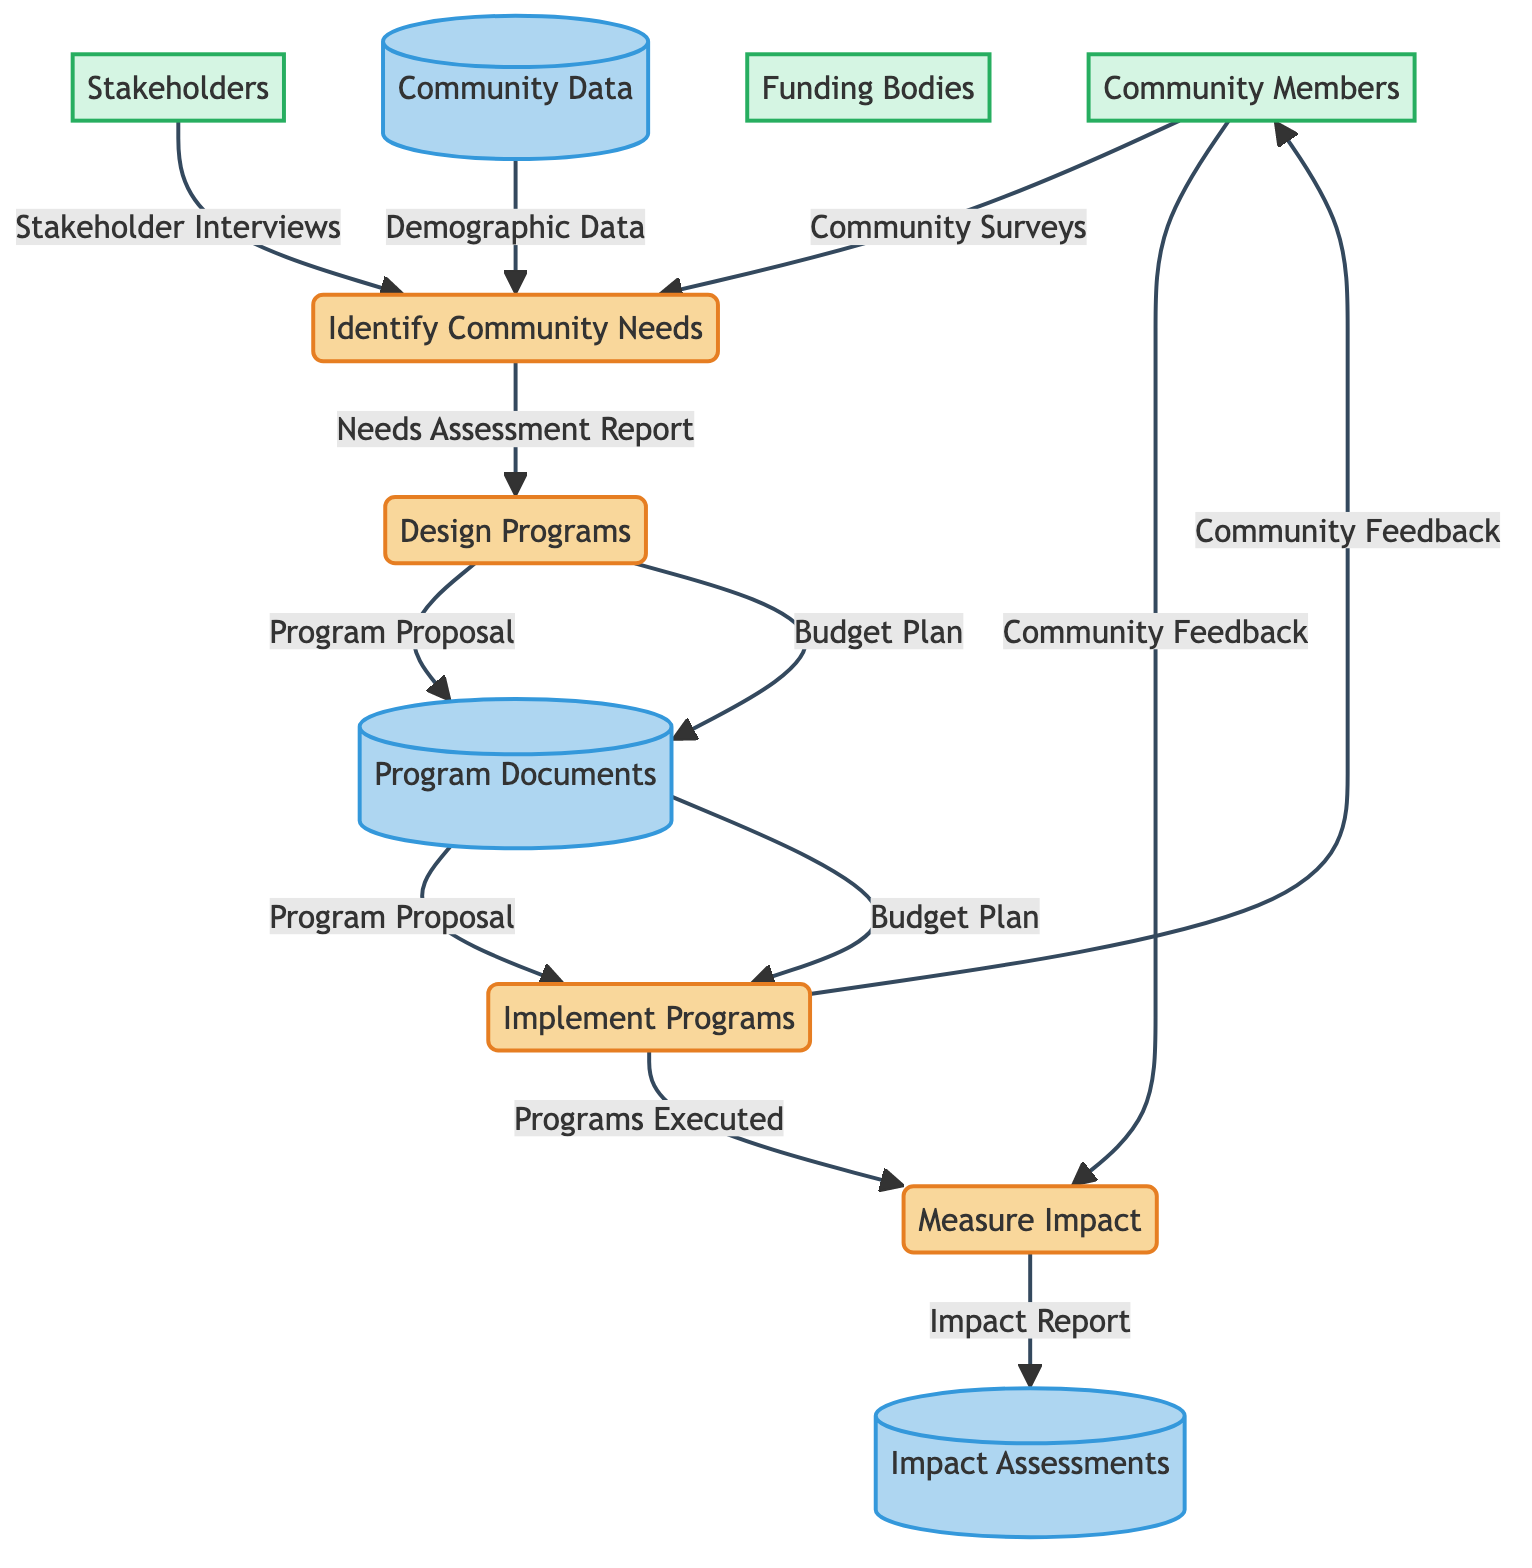What is the first process in the Community Program Development Cycle? The first process identified in the diagram is "Identify Community Needs," which serves as the starting point for the cycle of developing community programs.
Answer: Identify Community Needs How many total processes are present in the diagram? The diagram outlines a total of four processes, which include Identify Community Needs, Design Programs, Implement Programs, and Measure Impact.
Answer: 4 What data do Community Members provide to the first process? Community Members contribute "Community Surveys" to the "Identify Community Needs" process, which is used to gather input on community needs.
Answer: Community Surveys Which process uses the Needs Assessment Report as input? The process that utilizes the Needs Assessment Report as input is "Design Programs," which relies on this assessment to create program proposals.
Answer: Design Programs What is the output of the Measure Impact process? The output generated by the Measure Impact process is the "Impact Report," which evaluates the effectiveness of the programs that have been implemented.
Answer: Impact Report How does the Implement Programs process acquire community feedback? The Implement Programs process receives community feedback directly from Community Members, who participate in providing their input after the programs are executed.
Answer: Community Feedback Which external entity is involved in providing Stakeholder Interviews? The external entity involved in providing Stakeholder Interviews is "Stakeholders," who are key individuals and organizations contributing to the needs assessment.
Answer: Stakeholders What is the purpose of the Community Data data store? The purpose of the Community Data data store is to maintain a database containing community surveys, stakeholder interviews, and demographic data essential for identifying community needs.
Answer: Database containing community surveys, stakeholder interviews, and demographic data Which process leads to the execution of programs in the community? The process that leads to the execution of programs in the community is "Implement Programs," which acts on the developed program proposals and budget plans.
Answer: Implement Programs 